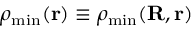Convert formula to latex. <formula><loc_0><loc_0><loc_500><loc_500>\rho _ { \min } ( { r } ) \equiv \rho _ { \min } ( { R } , { r } )</formula> 